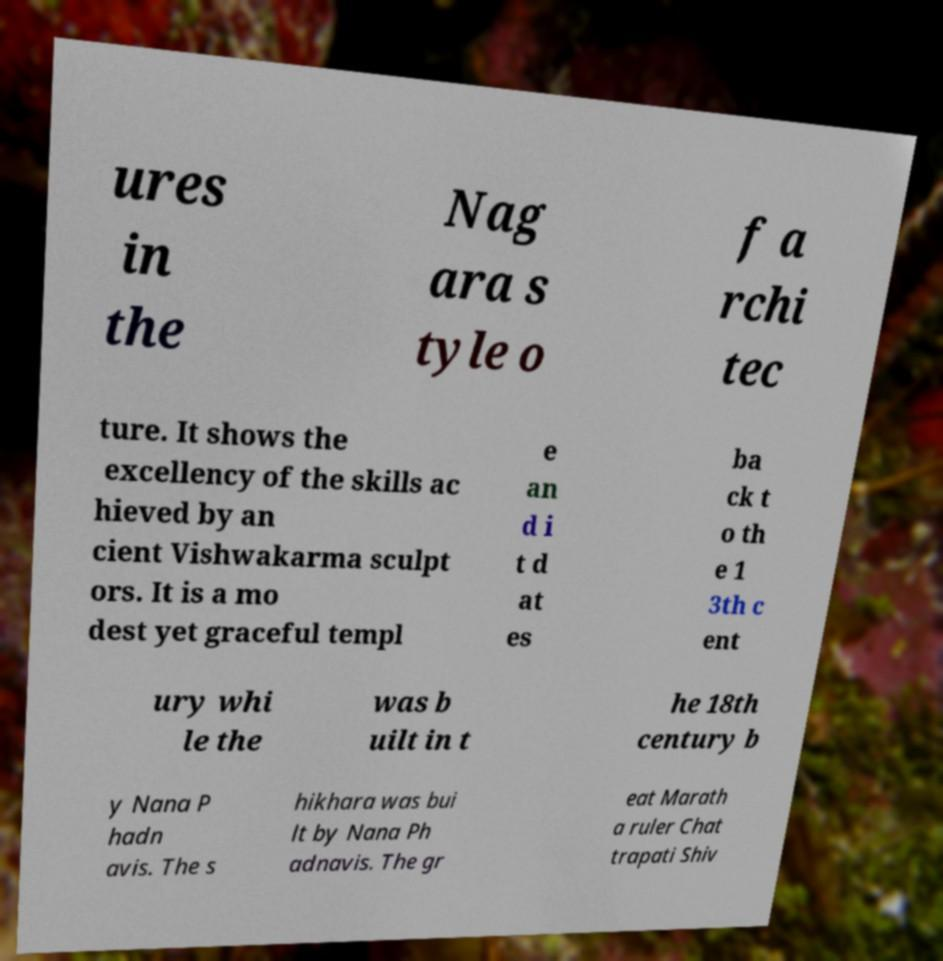Please identify and transcribe the text found in this image. ures in the Nag ara s tyle o f a rchi tec ture. It shows the excellency of the skills ac hieved by an cient Vishwakarma sculpt ors. It is a mo dest yet graceful templ e an d i t d at es ba ck t o th e 1 3th c ent ury whi le the was b uilt in t he 18th century b y Nana P hadn avis. The s hikhara was bui lt by Nana Ph adnavis. The gr eat Marath a ruler Chat trapati Shiv 